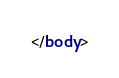<code> <loc_0><loc_0><loc_500><loc_500><_HTML_></body>
</code> 